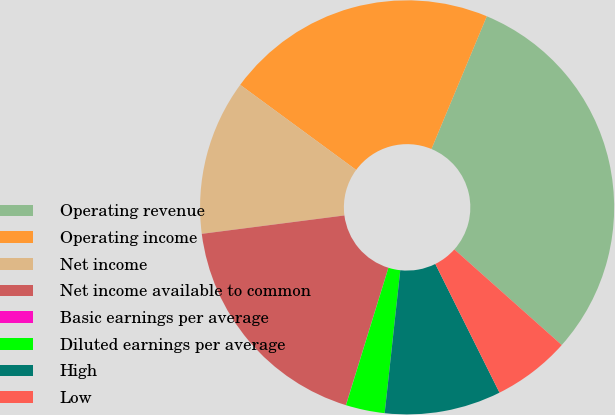Convert chart. <chart><loc_0><loc_0><loc_500><loc_500><pie_chart><fcel>Operating revenue<fcel>Operating income<fcel>Net income<fcel>Net income available to common<fcel>Basic earnings per average<fcel>Diluted earnings per average<fcel>High<fcel>Low<nl><fcel>30.29%<fcel>21.21%<fcel>12.12%<fcel>18.18%<fcel>0.01%<fcel>3.04%<fcel>9.09%<fcel>6.06%<nl></chart> 